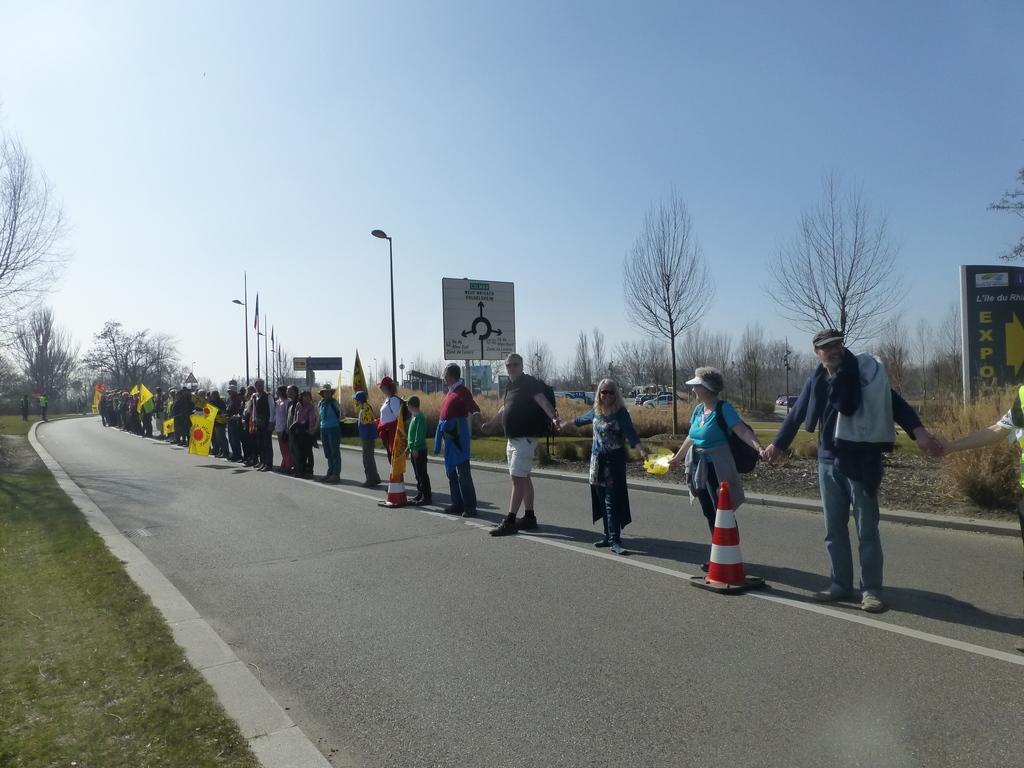Can you describe this image briefly? Here we can see group of people on the road and they are holding flags with their hands. Here we can see traffic cones, poles, boards, and trees. This is grass. In the background there is sky. 